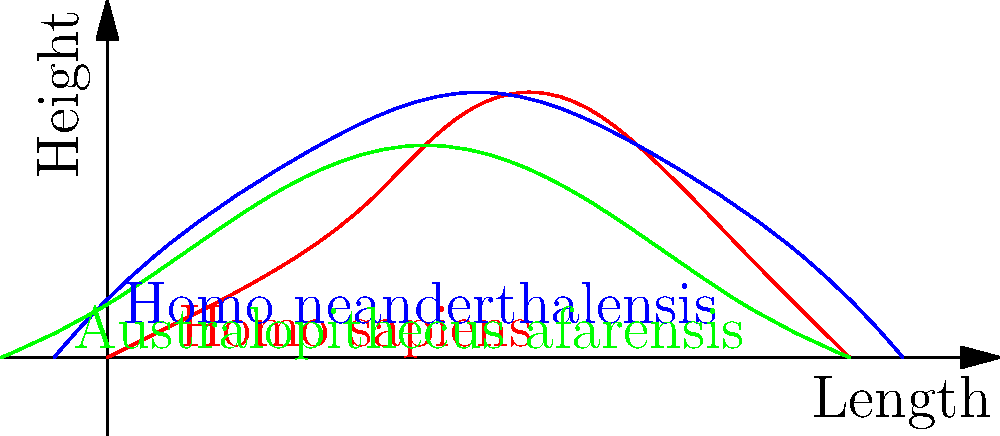Based on the overlaid silhouettes of three hominid species' skulls, which species demonstrates the most pronounced forehead and cranial capacity, indicating a larger brain size? To answer this question, we need to analyze the skull shapes of the three hominid species presented in the graphic:

1. Homo sapiens (red): This skull shows a high, rounded forehead and a large, domed cranium.
2. Homo neanderthalensis (blue): This skull has a slightly sloping forehead and a large, elongated cranium.
3. Australopithecus afarensis (green): This skull has a flatter, more sloping forehead and a smaller cranium.

Step-by-step analysis:
1. Compare the forehead shapes:
   - Homo sapiens has the most vertical and pronounced forehead.
   - Homo neanderthalensis has a slightly sloping forehead.
   - Australopithecus afarensis has the flattest, most sloping forehead.

2. Examine the cranial capacity:
   - Homo sapiens shows the largest, most rounded cranium.
   - Homo neanderthalensis has a large but slightly less rounded cranium.
   - Australopithecus afarensis has the smallest cranium.

3. Consider the implications for brain size:
   - A more pronounced forehead and larger cranial capacity generally indicate a larger brain size.
   - The vertical forehead of Homo sapiens suggests the frontal lobe is well-developed.
   - The overall larger and more rounded cranium of Homo sapiens implies a greater total brain volume.

Based on these observations, we can conclude that Homo sapiens demonstrates the most pronounced forehead and cranial capacity, indicating the largest brain size among the three species shown.
Answer: Homo sapiens 